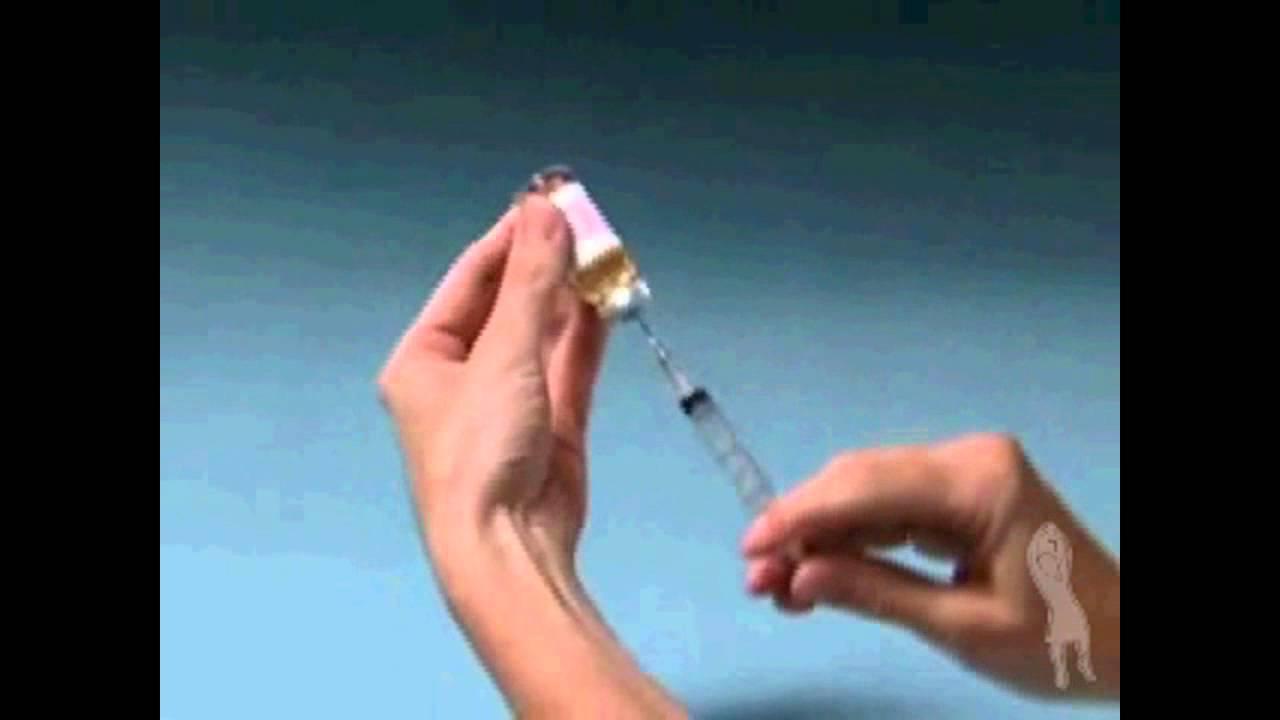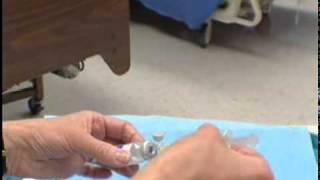The first image is the image on the left, the second image is the image on the right. Assess this claim about the two images: "At least one needle attached to a syringe is visible.". Correct or not? Answer yes or no. Yes. The first image is the image on the left, the second image is the image on the right. For the images shown, is this caption "There are four bare hands working with needles." true? Answer yes or no. Yes. 